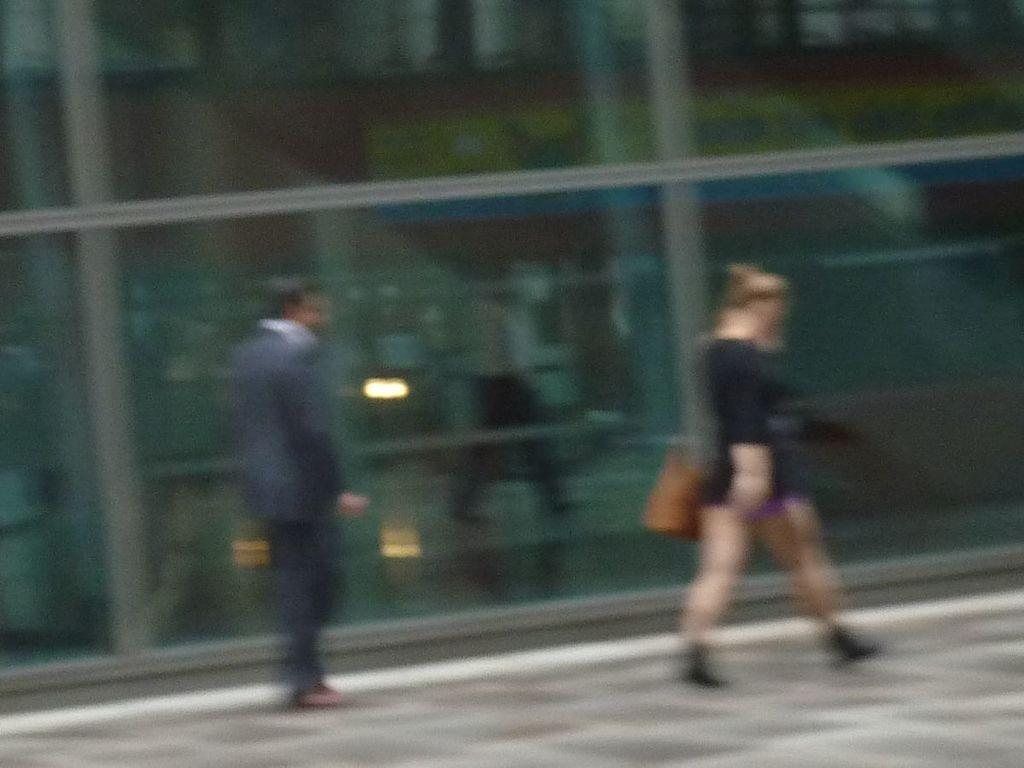What is happening on the left side of the image? There is a person standing on the left side of the image. What is happening on the right side of the image? There is a woman walking on the right side of the image. What is the woman holding in the image? The woman is holding a wall in the image. What type of wall can be seen in the background of the image? There is a glass wall in the background of the image. Can you see any matches or a curtain in the image? No, there are no matches or curtains present in the image. Is there any quartz visible in the image? No, there is no quartz visible in the image. 